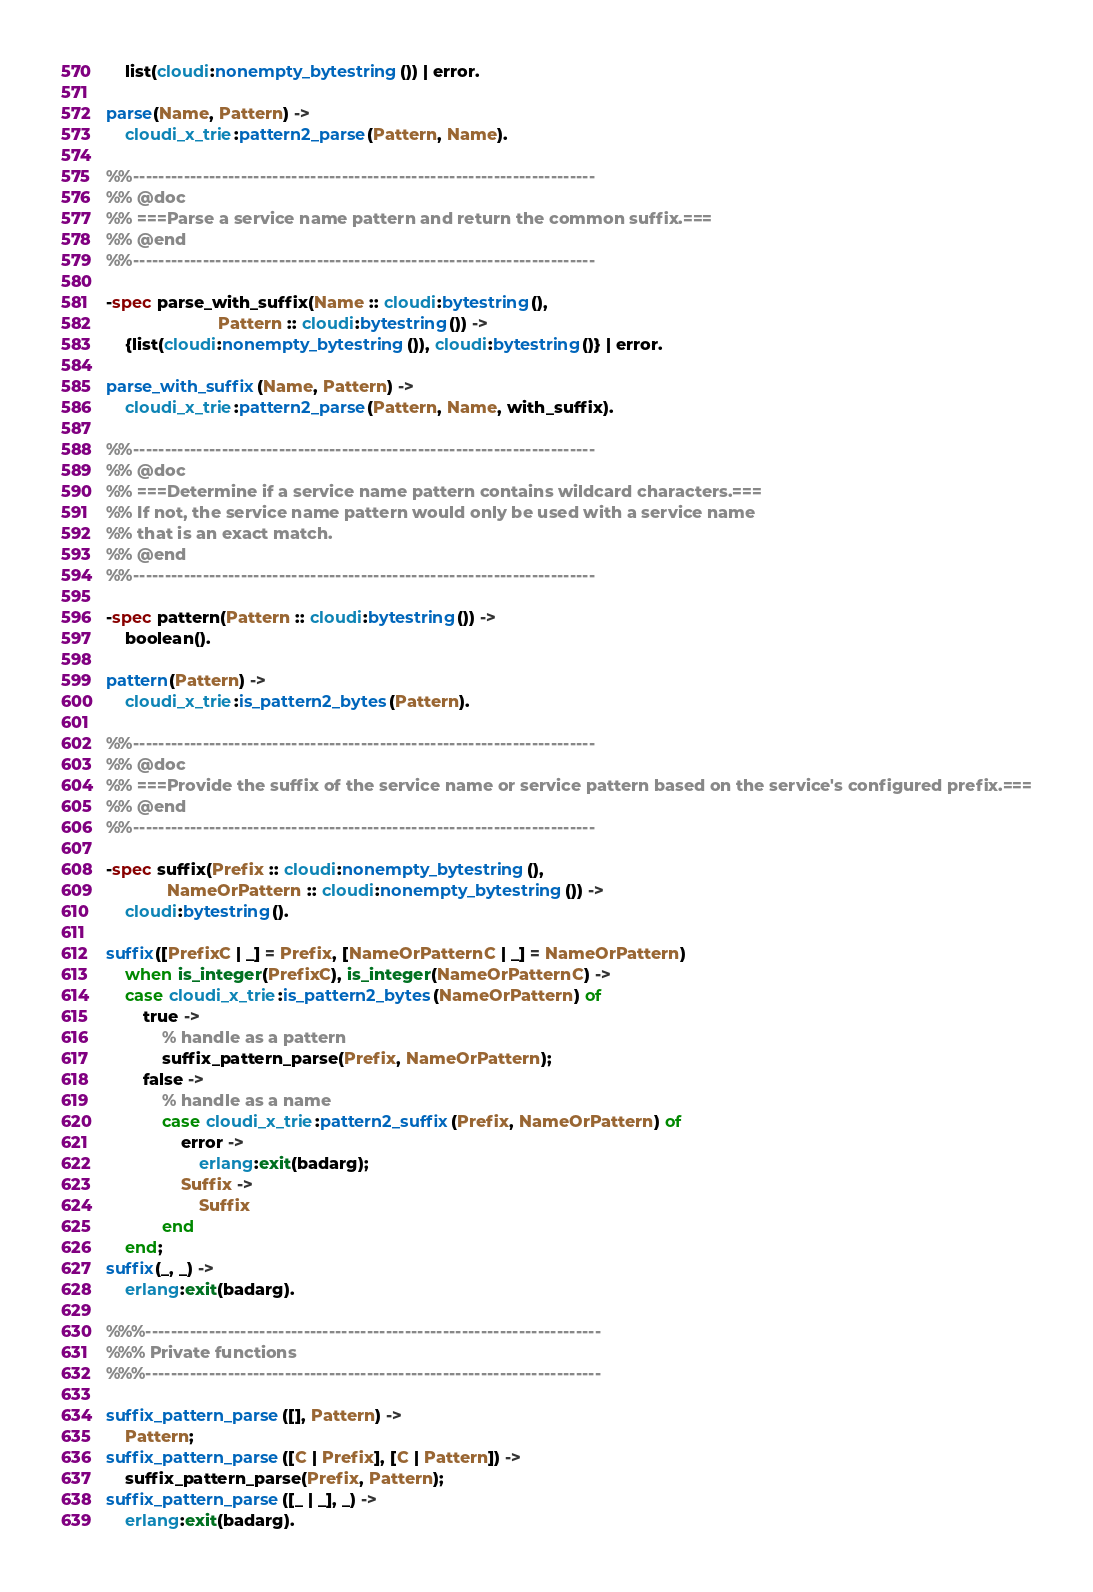<code> <loc_0><loc_0><loc_500><loc_500><_Erlang_>    list(cloudi:nonempty_bytestring()) | error.

parse(Name, Pattern) ->
    cloudi_x_trie:pattern2_parse(Pattern, Name).

%%-------------------------------------------------------------------------
%% @doc
%% ===Parse a service name pattern and return the common suffix.===
%% @end
%%-------------------------------------------------------------------------

-spec parse_with_suffix(Name :: cloudi:bytestring(),
                        Pattern :: cloudi:bytestring()) ->
    {list(cloudi:nonempty_bytestring()), cloudi:bytestring()} | error.

parse_with_suffix(Name, Pattern) ->
    cloudi_x_trie:pattern2_parse(Pattern, Name, with_suffix).

%%-------------------------------------------------------------------------
%% @doc
%% ===Determine if a service name pattern contains wildcard characters.===
%% If not, the service name pattern would only be used with a service name
%% that is an exact match.
%% @end
%%-------------------------------------------------------------------------

-spec pattern(Pattern :: cloudi:bytestring()) ->
    boolean().

pattern(Pattern) ->
    cloudi_x_trie:is_pattern2_bytes(Pattern).

%%-------------------------------------------------------------------------
%% @doc
%% ===Provide the suffix of the service name or service pattern based on the service's configured prefix.===
%% @end
%%-------------------------------------------------------------------------

-spec suffix(Prefix :: cloudi:nonempty_bytestring(),
             NameOrPattern :: cloudi:nonempty_bytestring()) ->
    cloudi:bytestring().

suffix([PrefixC | _] = Prefix, [NameOrPatternC | _] = NameOrPattern)
    when is_integer(PrefixC), is_integer(NameOrPatternC) ->
    case cloudi_x_trie:is_pattern2_bytes(NameOrPattern) of
        true ->
            % handle as a pattern
            suffix_pattern_parse(Prefix, NameOrPattern);
        false ->
            % handle as a name
            case cloudi_x_trie:pattern2_suffix(Prefix, NameOrPattern) of
                error ->
                    erlang:exit(badarg);
                Suffix ->
                    Suffix
            end
    end;
suffix(_, _) ->
    erlang:exit(badarg).

%%%------------------------------------------------------------------------
%%% Private functions
%%%------------------------------------------------------------------------

suffix_pattern_parse([], Pattern) ->
    Pattern;
suffix_pattern_parse([C | Prefix], [C | Pattern]) ->
    suffix_pattern_parse(Prefix, Pattern);
suffix_pattern_parse([_ | _], _) ->
    erlang:exit(badarg).
</code> 